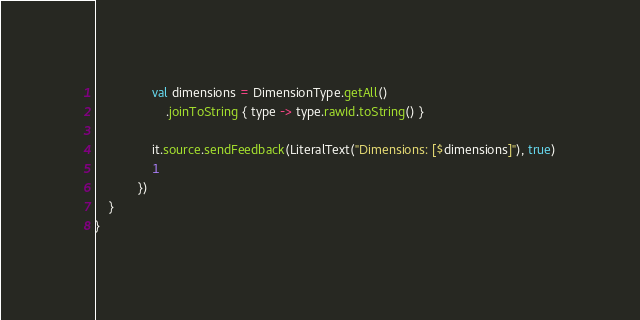Convert code to text. <code><loc_0><loc_0><loc_500><loc_500><_Kotlin_>                val dimensions = DimensionType.getAll()
                    .joinToString { type -> type.rawId.toString() }

                it.source.sendFeedback(LiteralText("Dimensions: [$dimensions]"), true)
                1
            })
    }
}</code> 